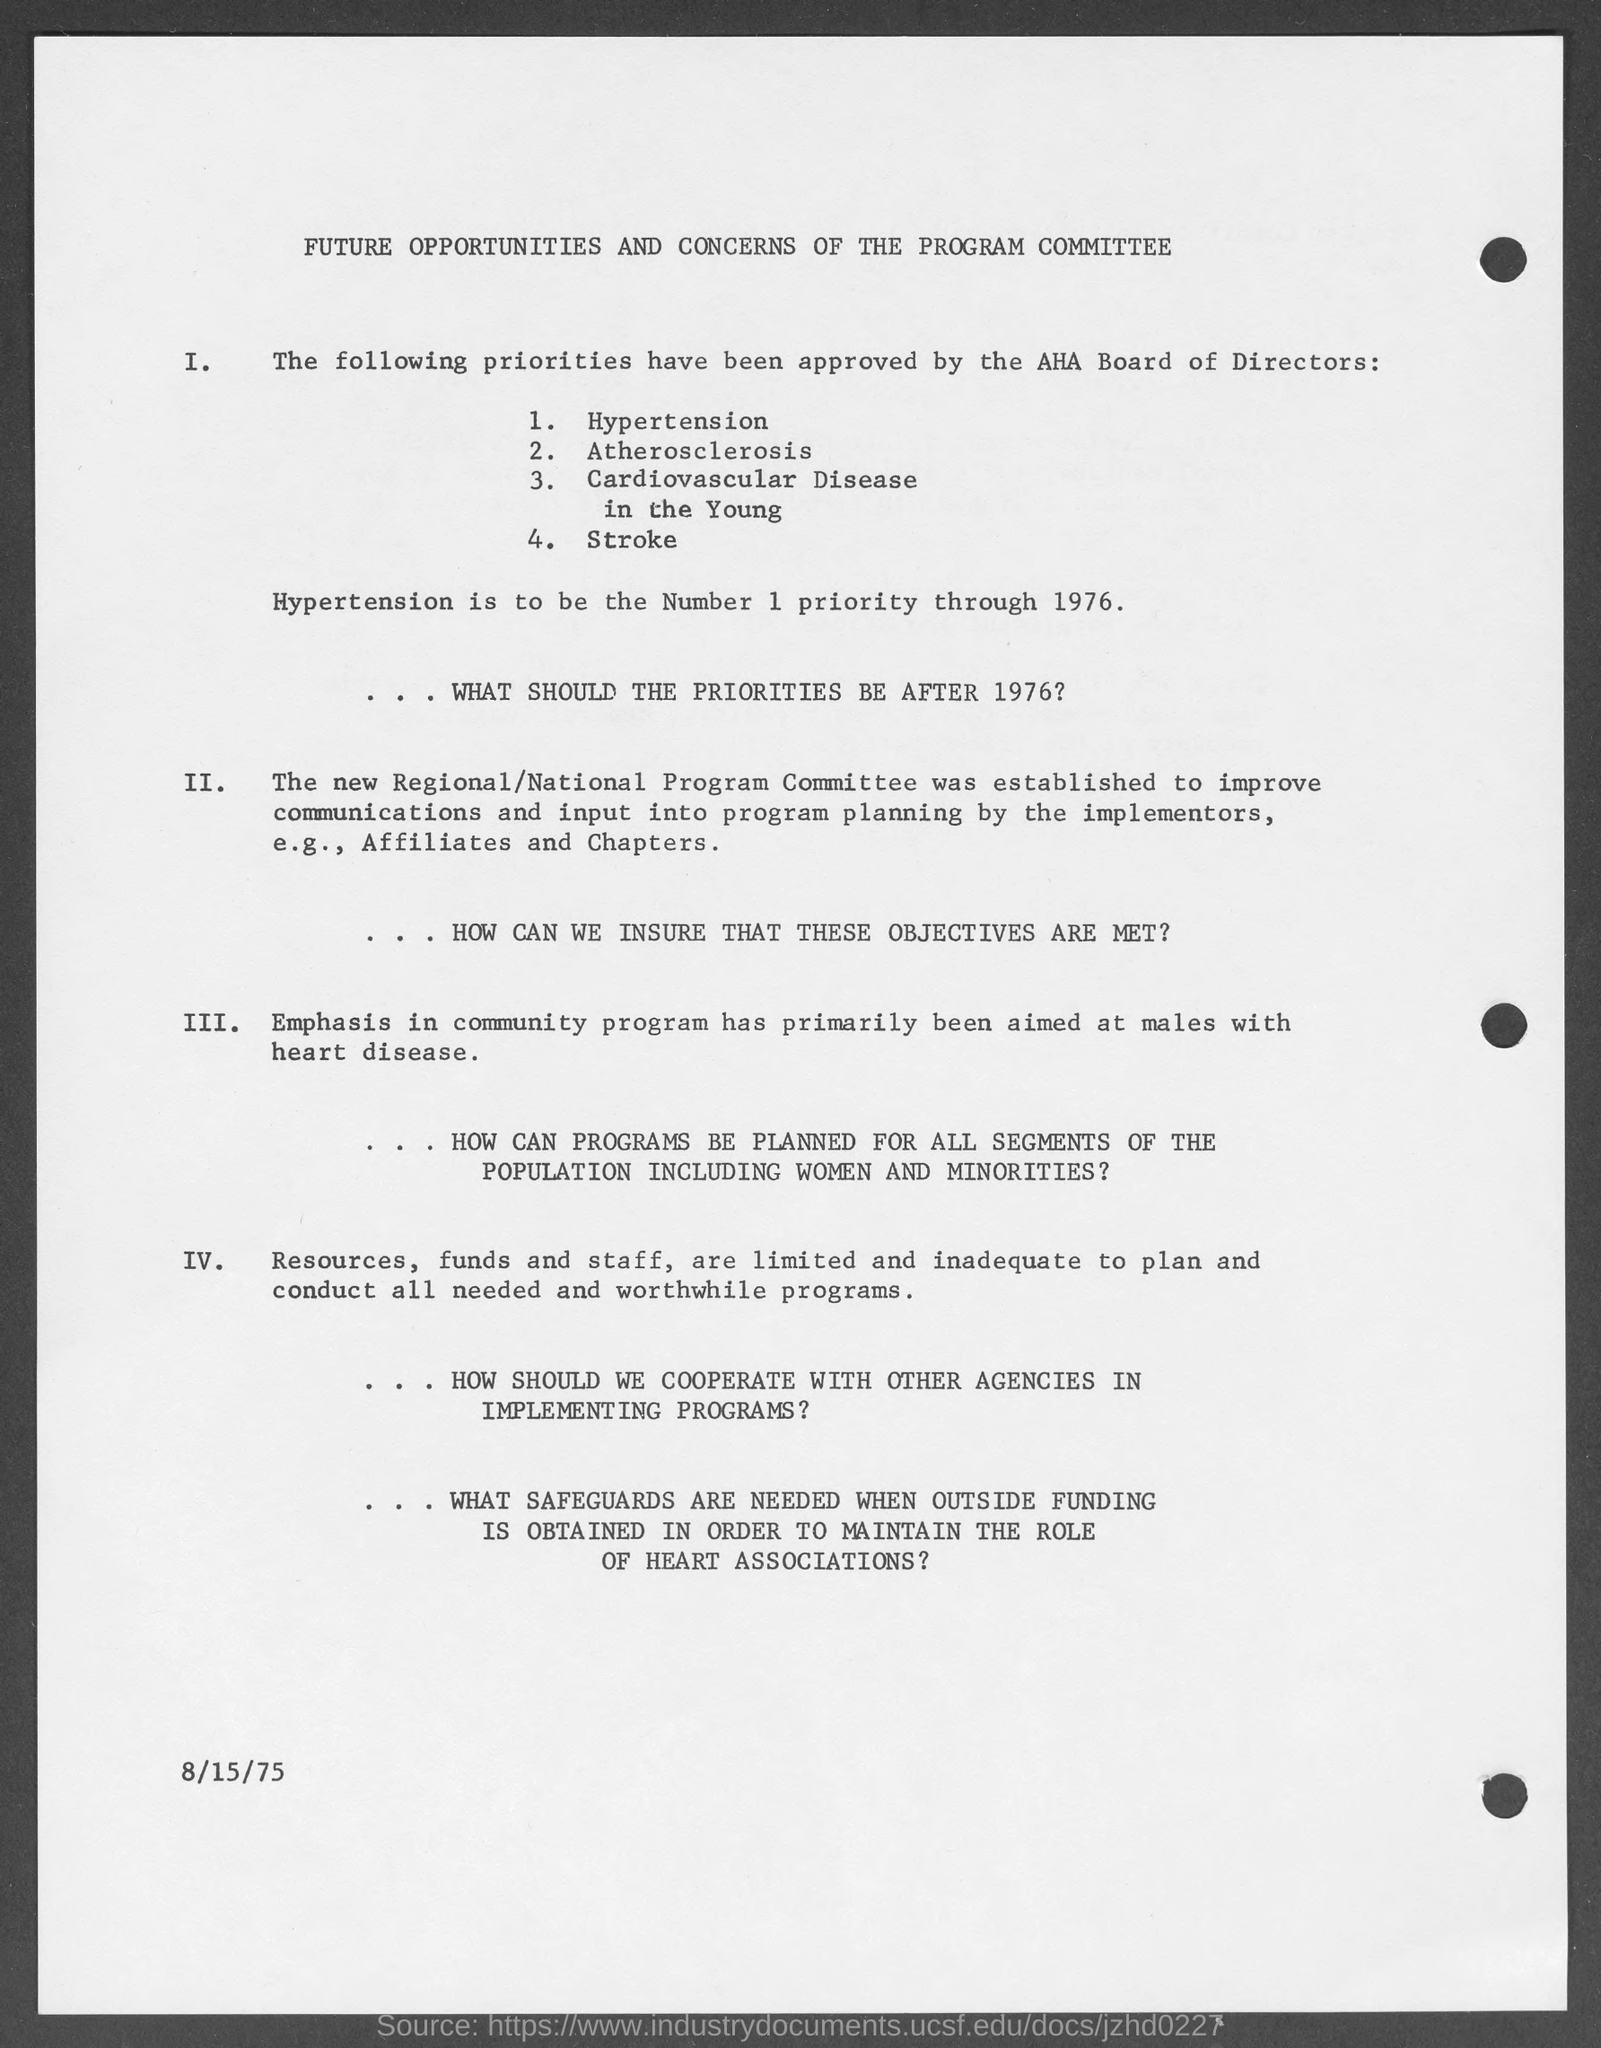Mention a couple of crucial points in this snapshot. The date at the bottom of the page is August 15, 1975. The American Heart Association (AHA) Board of Directors has designated stroke as the fourth highest priority. Hypertension was the number one priority in health care from 1976 until (date). The AHA Board of Directors has designated atherosclerosis as the second highest priority, as approved. The American Heart Association Board of Directors has designated cardiovascular disease in the young as a top priority, which was approved. 